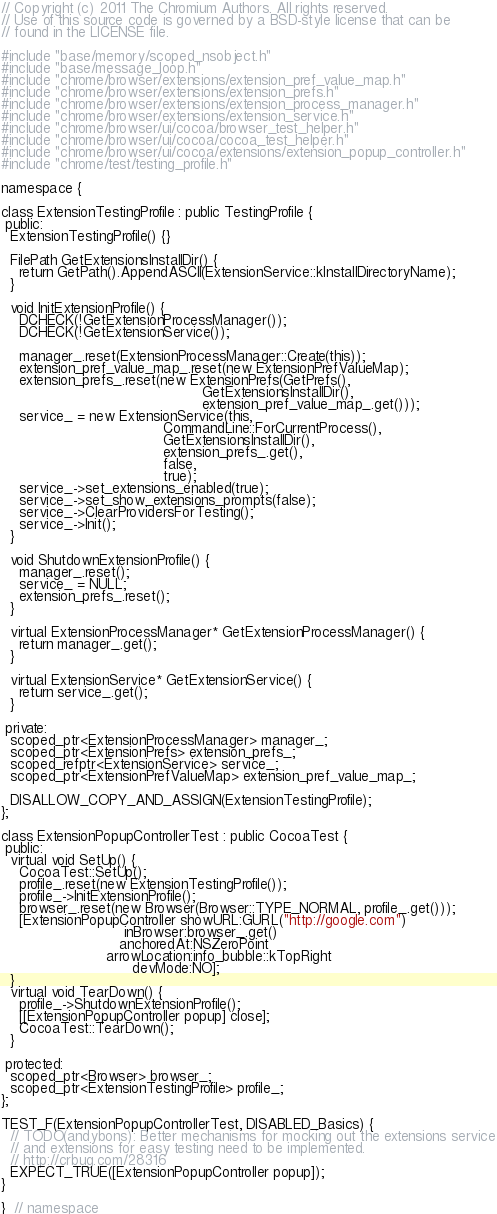Convert code to text. <code><loc_0><loc_0><loc_500><loc_500><_ObjectiveC_>// Copyright (c) 2011 The Chromium Authors. All rights reserved.
// Use of this source code is governed by a BSD-style license that can be
// found in the LICENSE file.

#include "base/memory/scoped_nsobject.h"
#include "base/message_loop.h"
#include "chrome/browser/extensions/extension_pref_value_map.h"
#include "chrome/browser/extensions/extension_prefs.h"
#include "chrome/browser/extensions/extension_process_manager.h"
#include "chrome/browser/extensions/extension_service.h"
#include "chrome/browser/ui/cocoa/browser_test_helper.h"
#include "chrome/browser/ui/cocoa/cocoa_test_helper.h"
#include "chrome/browser/ui/cocoa/extensions/extension_popup_controller.h"
#include "chrome/test/testing_profile.h"

namespace {

class ExtensionTestingProfile : public TestingProfile {
 public:
  ExtensionTestingProfile() {}

  FilePath GetExtensionsInstallDir() {
    return GetPath().AppendASCII(ExtensionService::kInstallDirectoryName);
  }

  void InitExtensionProfile() {
    DCHECK(!GetExtensionProcessManager());
    DCHECK(!GetExtensionService());

    manager_.reset(ExtensionProcessManager::Create(this));
    extension_pref_value_map_.reset(new ExtensionPrefValueMap);
    extension_prefs_.reset(new ExtensionPrefs(GetPrefs(),
                                              GetExtensionsInstallDir(),
                                              extension_pref_value_map_.get()));
    service_ = new ExtensionService(this,
                                     CommandLine::ForCurrentProcess(),
                                     GetExtensionsInstallDir(),
                                     extension_prefs_.get(),
                                     false,
                                     true);
    service_->set_extensions_enabled(true);
    service_->set_show_extensions_prompts(false);
    service_->ClearProvidersForTesting();
    service_->Init();
  }

  void ShutdownExtensionProfile() {
    manager_.reset();
    service_ = NULL;
    extension_prefs_.reset();
  }

  virtual ExtensionProcessManager* GetExtensionProcessManager() {
    return manager_.get();
  }

  virtual ExtensionService* GetExtensionService() {
    return service_.get();
  }

 private:
  scoped_ptr<ExtensionProcessManager> manager_;
  scoped_ptr<ExtensionPrefs> extension_prefs_;
  scoped_refptr<ExtensionService> service_;
  scoped_ptr<ExtensionPrefValueMap> extension_pref_value_map_;

  DISALLOW_COPY_AND_ASSIGN(ExtensionTestingProfile);
};

class ExtensionPopupControllerTest : public CocoaTest {
 public:
  virtual void SetUp() {
    CocoaTest::SetUp();
    profile_.reset(new ExtensionTestingProfile());
    profile_->InitExtensionProfile();
    browser_.reset(new Browser(Browser::TYPE_NORMAL, profile_.get()));
    [ExtensionPopupController showURL:GURL("http://google.com")
                            inBrowser:browser_.get()
                           anchoredAt:NSZeroPoint
                        arrowLocation:info_bubble::kTopRight
                              devMode:NO];
  }
  virtual void TearDown() {
    profile_->ShutdownExtensionProfile();
    [[ExtensionPopupController popup] close];
    CocoaTest::TearDown();
  }

 protected:
  scoped_ptr<Browser> browser_;
  scoped_ptr<ExtensionTestingProfile> profile_;
};

TEST_F(ExtensionPopupControllerTest, DISABLED_Basics) {
  // TODO(andybons): Better mechanisms for mocking out the extensions service
  // and extensions for easy testing need to be implemented.
  // http://crbug.com/28316
  EXPECT_TRUE([ExtensionPopupController popup]);
}

}  // namespace
</code> 